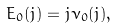Convert formula to latex. <formula><loc_0><loc_0><loc_500><loc_500>E _ { 0 } ( j ) = j \nu _ { 0 } ( j ) ,</formula> 